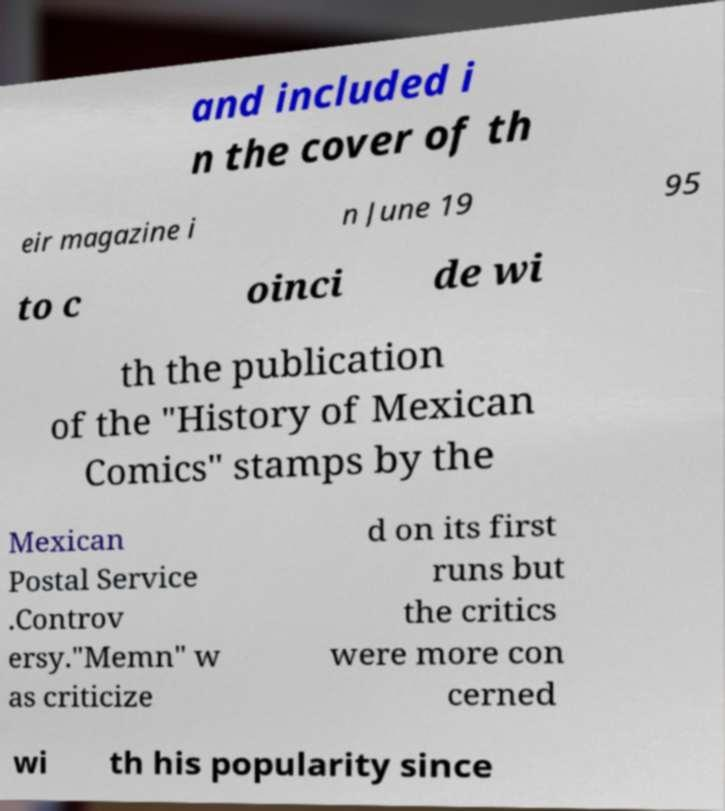Please read and relay the text visible in this image. What does it say? and included i n the cover of th eir magazine i n June 19 95 to c oinci de wi th the publication of the "History of Mexican Comics" stamps by the Mexican Postal Service .Controv ersy."Memn" w as criticize d on its first runs but the critics were more con cerned wi th his popularity since 